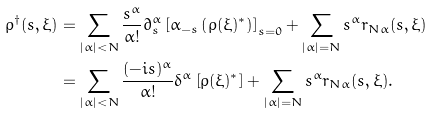<formula> <loc_0><loc_0><loc_500><loc_500>\rho ^ { \dagger } ( s , \xi ) & = \sum _ { | \alpha | < N } \frac { s ^ { \alpha } } { \alpha ! } \partial _ { s } ^ { \alpha } \left [ \alpha _ { - s } \left ( \rho ( \xi ) ^ { * } \right ) \right ] _ { s = 0 } + \sum _ { | \alpha | = N } s ^ { \alpha } r _ { N \alpha } ( s , \xi ) \\ & = \sum _ { | \alpha | < N } \frac { ( - i s ) ^ { \alpha } } { \alpha ! } \delta ^ { \alpha } \left [ \rho ( \xi ) ^ { * } \right ] + \sum _ { | \alpha | = N } s ^ { \alpha } r _ { N \alpha } ( s , \xi ) .</formula> 